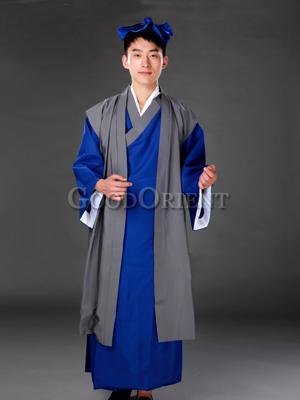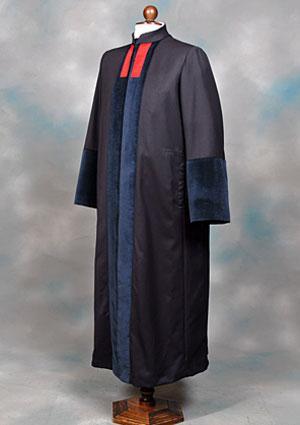The first image is the image on the left, the second image is the image on the right. Examine the images to the left and right. Is the description "A person is not shown in any of the images." accurate? Answer yes or no. No. 